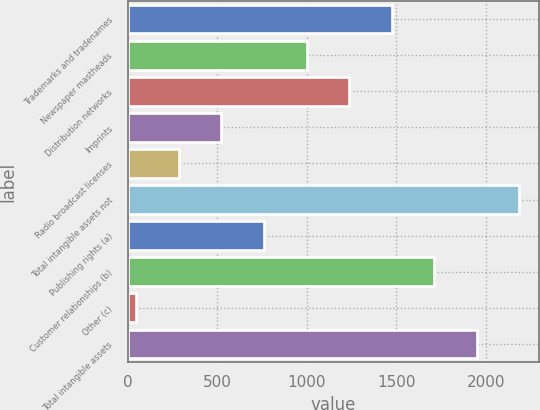Convert chart to OTSL. <chart><loc_0><loc_0><loc_500><loc_500><bar_chart><fcel>Trademarks and tradenames<fcel>Newspaper mastheads<fcel>Distribution networks<fcel>Imprints<fcel>Radio broadcast licenses<fcel>Total intangible assets not<fcel>Publishing rights (a)<fcel>Customer relationships (b)<fcel>Other (c)<fcel>Total intangible assets<nl><fcel>1474.4<fcel>998.6<fcel>1236.5<fcel>522.8<fcel>284.9<fcel>2188.1<fcel>760.7<fcel>1712.3<fcel>47<fcel>1950.2<nl></chart> 